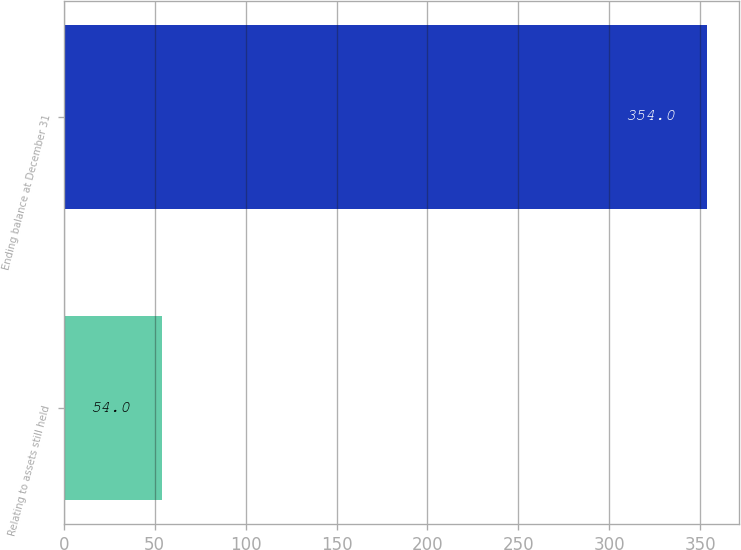Convert chart to OTSL. <chart><loc_0><loc_0><loc_500><loc_500><bar_chart><fcel>Relating to assets still held<fcel>Ending balance at December 31<nl><fcel>54<fcel>354<nl></chart> 